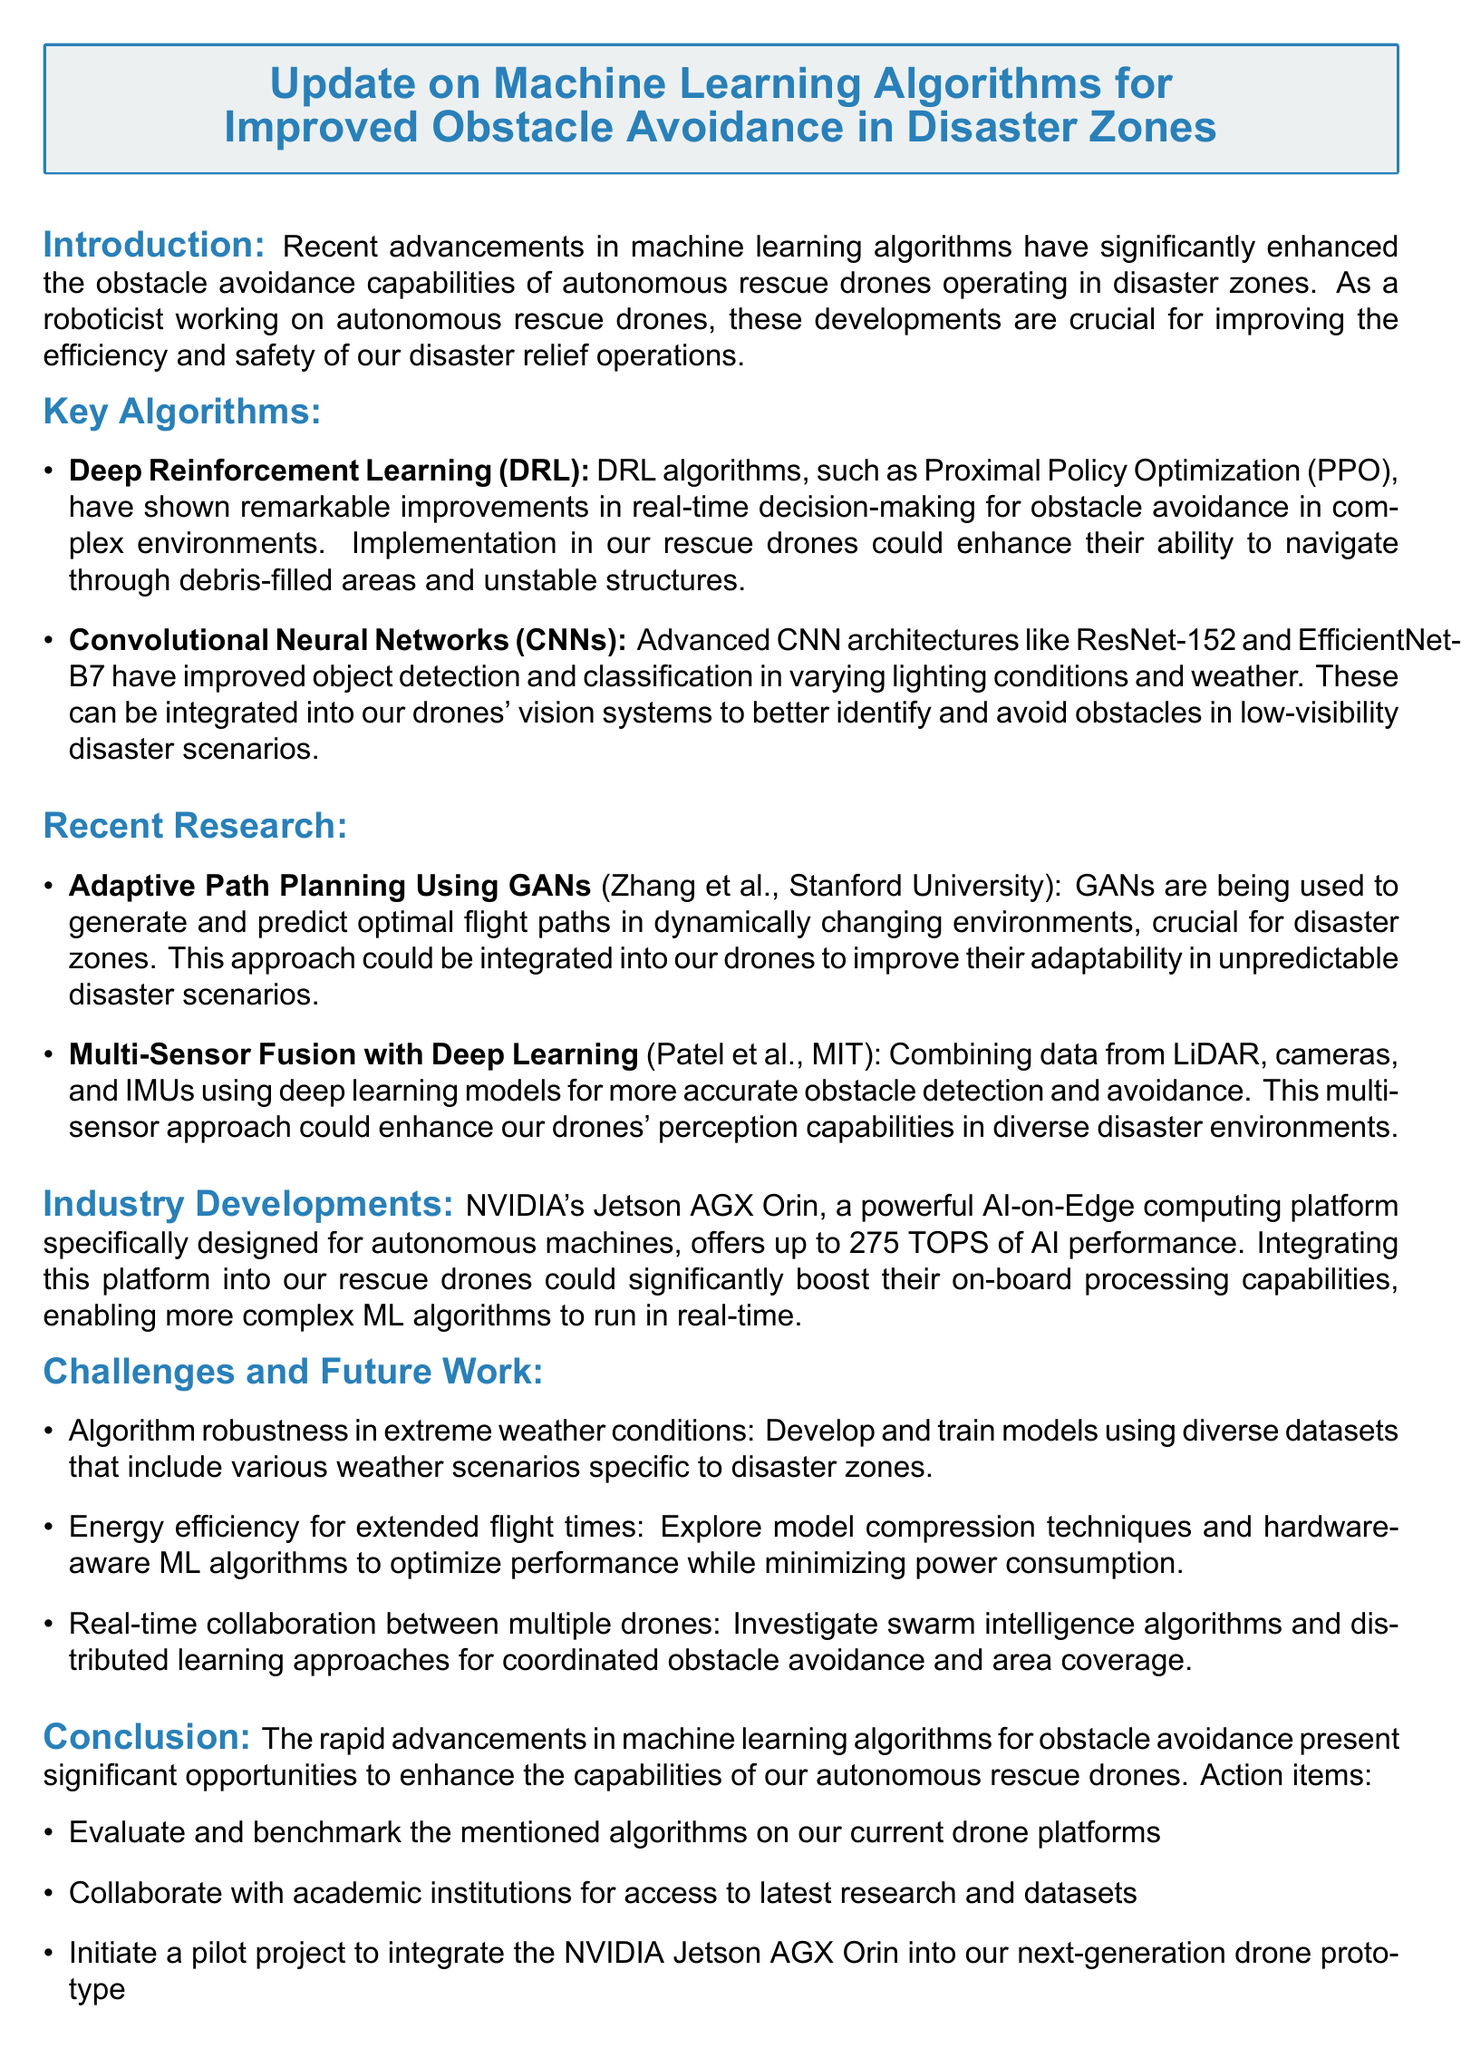What are the two key algorithms mentioned? The document lists Deep Reinforcement Learning (DRL) and Convolutional Neural Networks (CNNs) as the key algorithms.
Answer: Deep Reinforcement Learning (DRL), Convolutional Neural Networks (CNNs) Who are the authors of the research titled "Adaptive Path Planning Using GANs"? The authors of this research are Zhang et al. from Stanford University.
Answer: Zhang et al., Stanford University What computation platform is mentioned in the industry developments section? The platform mentioned is the NVIDIA Jetson AGX Orin.
Answer: NVIDIA Jetson AGX Orin What is the proposed solution for algorithm robustness in extreme weather conditions? The proposed solution is to develop and train models using diverse datasets that include various weather scenarios specific to disaster zones.
Answer: Develop and train models using diverse datasets What is the potential impact of integrating the Jetson AGX Orin into drones? Integrating this platform could significantly boost the drones' on-board processing capabilities, enabling more complex ML algorithms to run in real-time.
Answer: Boost on-board processing capabilities Which advanced CNN architectures are mentioned for improved object detection? The architectures mentioned are ResNet-152 and EfficientNet-B7.
Answer: ResNet-152, EfficientNet-B7 What action item involves collaboration with academic institutions? The action item is to collaborate with academic institutions for access to the latest research and datasets.
Answer: Collaborate with academic institutions What challenge relates to energy efficiency for extended flight times? The challenge is to explore model compression techniques and hardware-aware ML algorithms to optimize performance while minimizing power consumption.
Answer: Explore model compression techniques What does the conclusion highlight about the machine learning advancements? The conclusion summarizes that these advancements present significant opportunities to enhance the capabilities of autonomous rescue drones.
Answer: Significant opportunities to enhance capabilities 